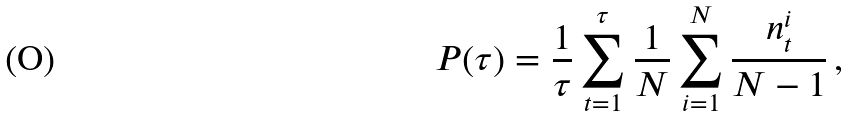<formula> <loc_0><loc_0><loc_500><loc_500>P ( \tau ) = \frac { 1 } { \tau } \sum _ { t = 1 } ^ { \tau } \frac { 1 } { N } \sum _ { i = 1 } ^ { N } \frac { n _ { t } ^ { i } } { N - 1 } \, ,</formula> 